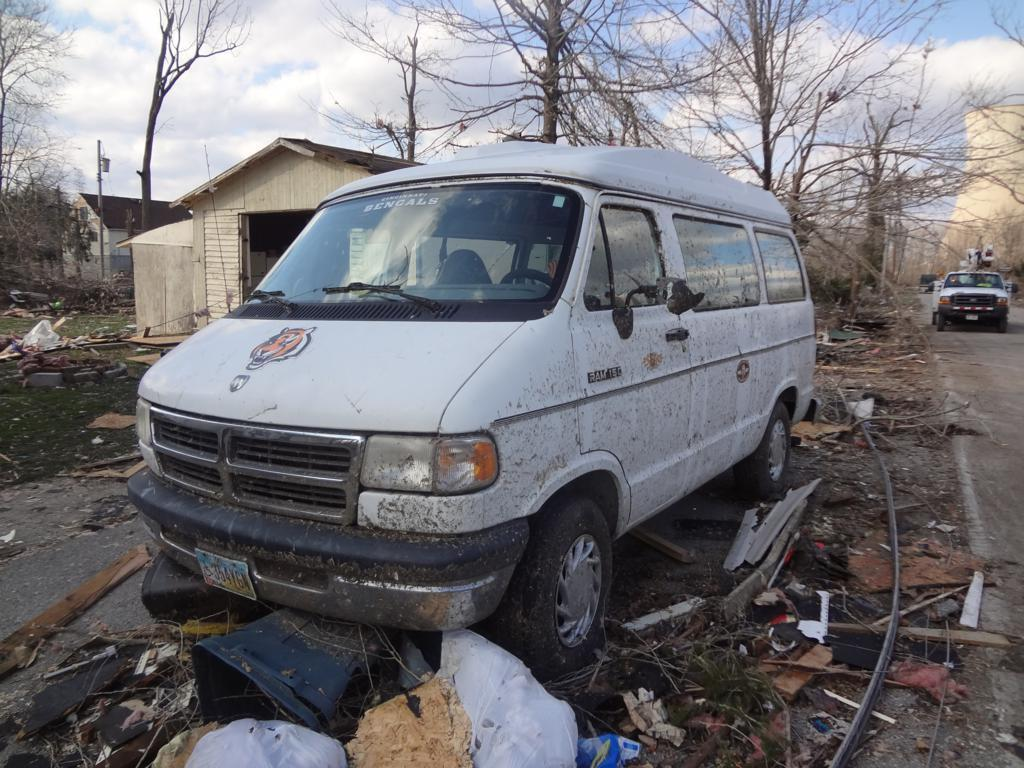<image>
Render a clear and concise summary of the photo. The white van is called a RAM 150 